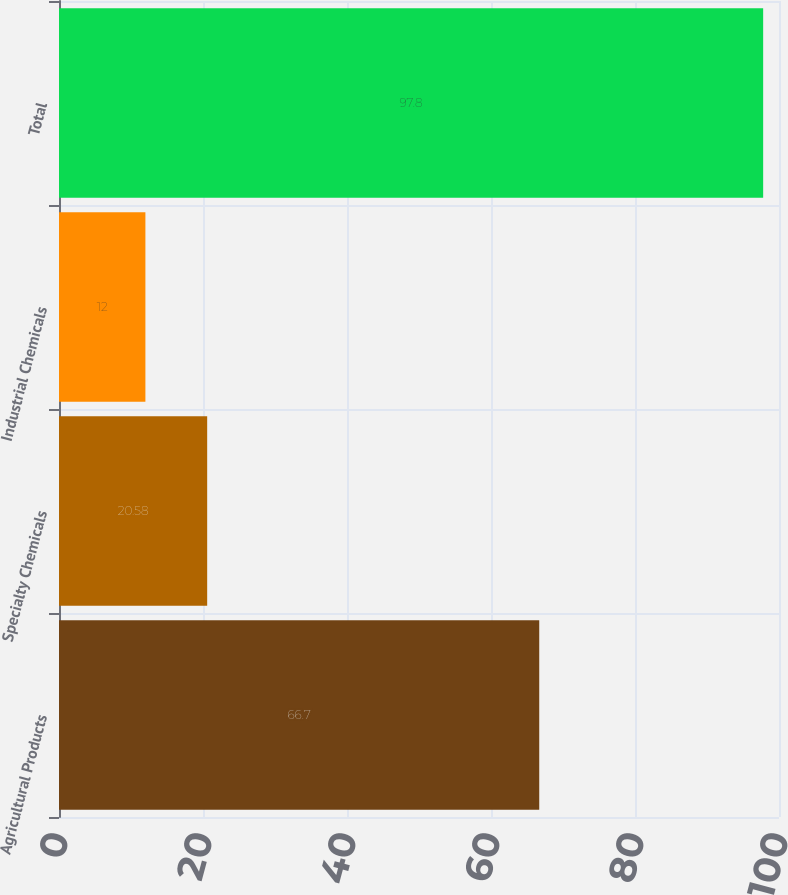Convert chart to OTSL. <chart><loc_0><loc_0><loc_500><loc_500><bar_chart><fcel>Agricultural Products<fcel>Specialty Chemicals<fcel>Industrial Chemicals<fcel>Total<nl><fcel>66.7<fcel>20.58<fcel>12<fcel>97.8<nl></chart> 